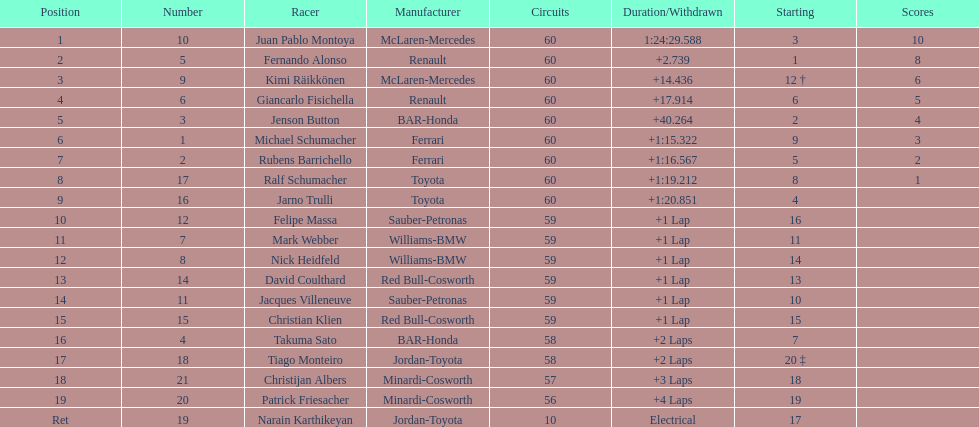Which driver came after giancarlo fisichella? Jenson Button. Parse the table in full. {'header': ['Position', 'Number', 'Racer', 'Manufacturer', 'Circuits', 'Duration/Withdrawn', 'Starting', 'Scores'], 'rows': [['1', '10', 'Juan Pablo Montoya', 'McLaren-Mercedes', '60', '1:24:29.588', '3', '10'], ['2', '5', 'Fernando Alonso', 'Renault', '60', '+2.739', '1', '8'], ['3', '9', 'Kimi Räikkönen', 'McLaren-Mercedes', '60', '+14.436', '12 †', '6'], ['4', '6', 'Giancarlo Fisichella', 'Renault', '60', '+17.914', '6', '5'], ['5', '3', 'Jenson Button', 'BAR-Honda', '60', '+40.264', '2', '4'], ['6', '1', 'Michael Schumacher', 'Ferrari', '60', '+1:15.322', '9', '3'], ['7', '2', 'Rubens Barrichello', 'Ferrari', '60', '+1:16.567', '5', '2'], ['8', '17', 'Ralf Schumacher', 'Toyota', '60', '+1:19.212', '8', '1'], ['9', '16', 'Jarno Trulli', 'Toyota', '60', '+1:20.851', '4', ''], ['10', '12', 'Felipe Massa', 'Sauber-Petronas', '59', '+1 Lap', '16', ''], ['11', '7', 'Mark Webber', 'Williams-BMW', '59', '+1 Lap', '11', ''], ['12', '8', 'Nick Heidfeld', 'Williams-BMW', '59', '+1 Lap', '14', ''], ['13', '14', 'David Coulthard', 'Red Bull-Cosworth', '59', '+1 Lap', '13', ''], ['14', '11', 'Jacques Villeneuve', 'Sauber-Petronas', '59', '+1 Lap', '10', ''], ['15', '15', 'Christian Klien', 'Red Bull-Cosworth', '59', '+1 Lap', '15', ''], ['16', '4', 'Takuma Sato', 'BAR-Honda', '58', '+2 Laps', '7', ''], ['17', '18', 'Tiago Monteiro', 'Jordan-Toyota', '58', '+2 Laps', '20 ‡', ''], ['18', '21', 'Christijan Albers', 'Minardi-Cosworth', '57', '+3 Laps', '18', ''], ['19', '20', 'Patrick Friesacher', 'Minardi-Cosworth', '56', '+4 Laps', '19', ''], ['Ret', '19', 'Narain Karthikeyan', 'Jordan-Toyota', '10', 'Electrical', '17', '']]} 